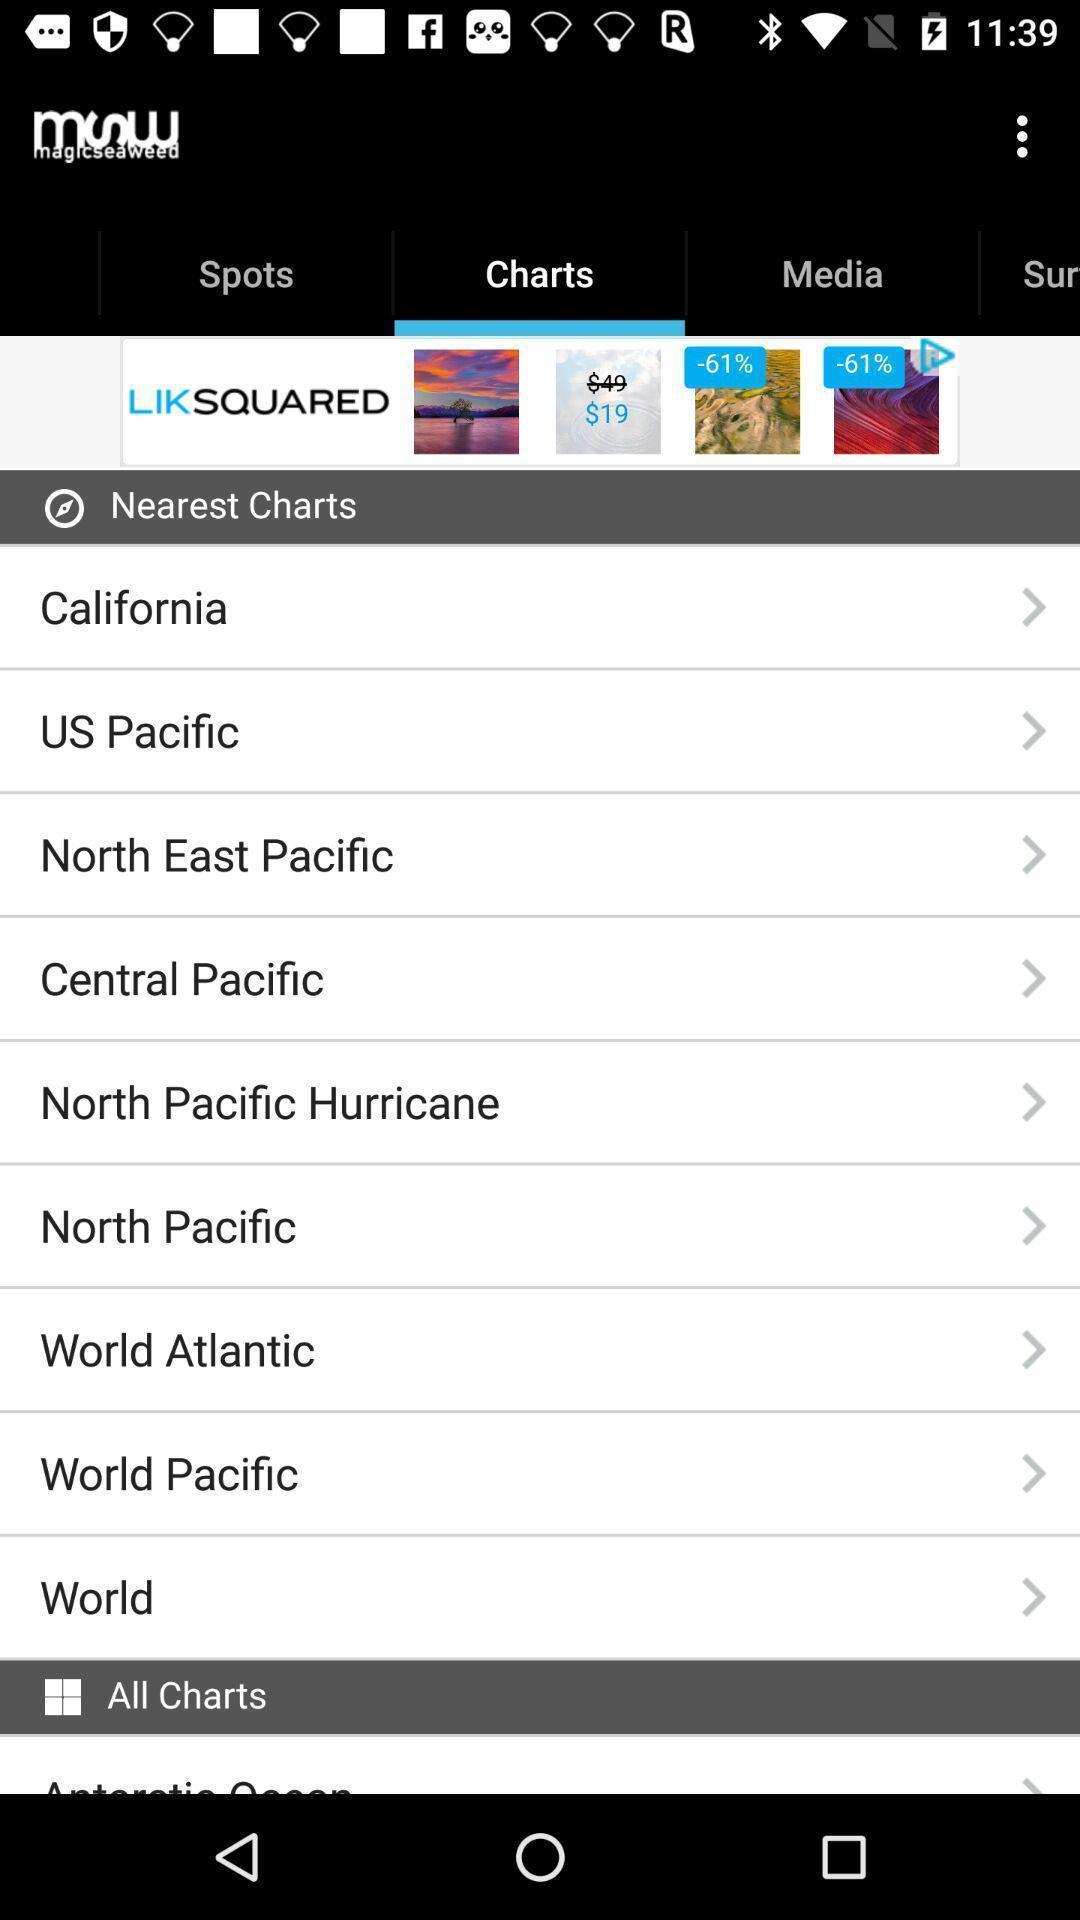Provide a textual representation of this image. Screen display charts page. 